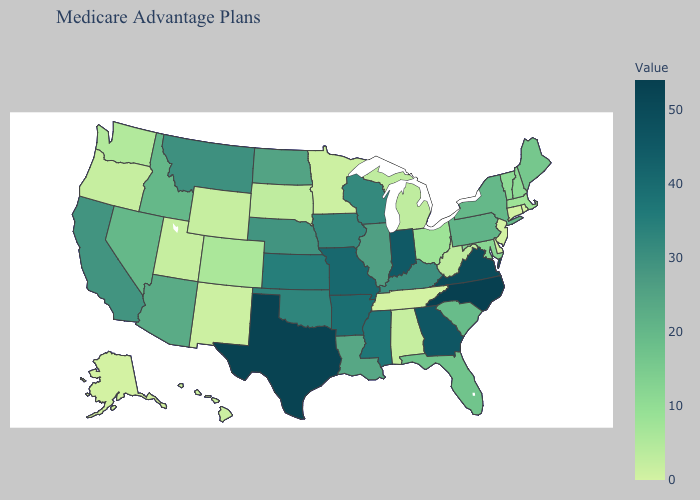Does Iowa have a higher value than Tennessee?
Quick response, please. Yes. Does the map have missing data?
Concise answer only. No. Among the states that border Tennessee , which have the highest value?
Quick response, please. North Carolina. Which states have the highest value in the USA?
Write a very short answer. North Carolina. Among the states that border California , which have the highest value?
Short answer required. Arizona. Among the states that border Vermont , which have the lowest value?
Answer briefly. Massachusetts. 